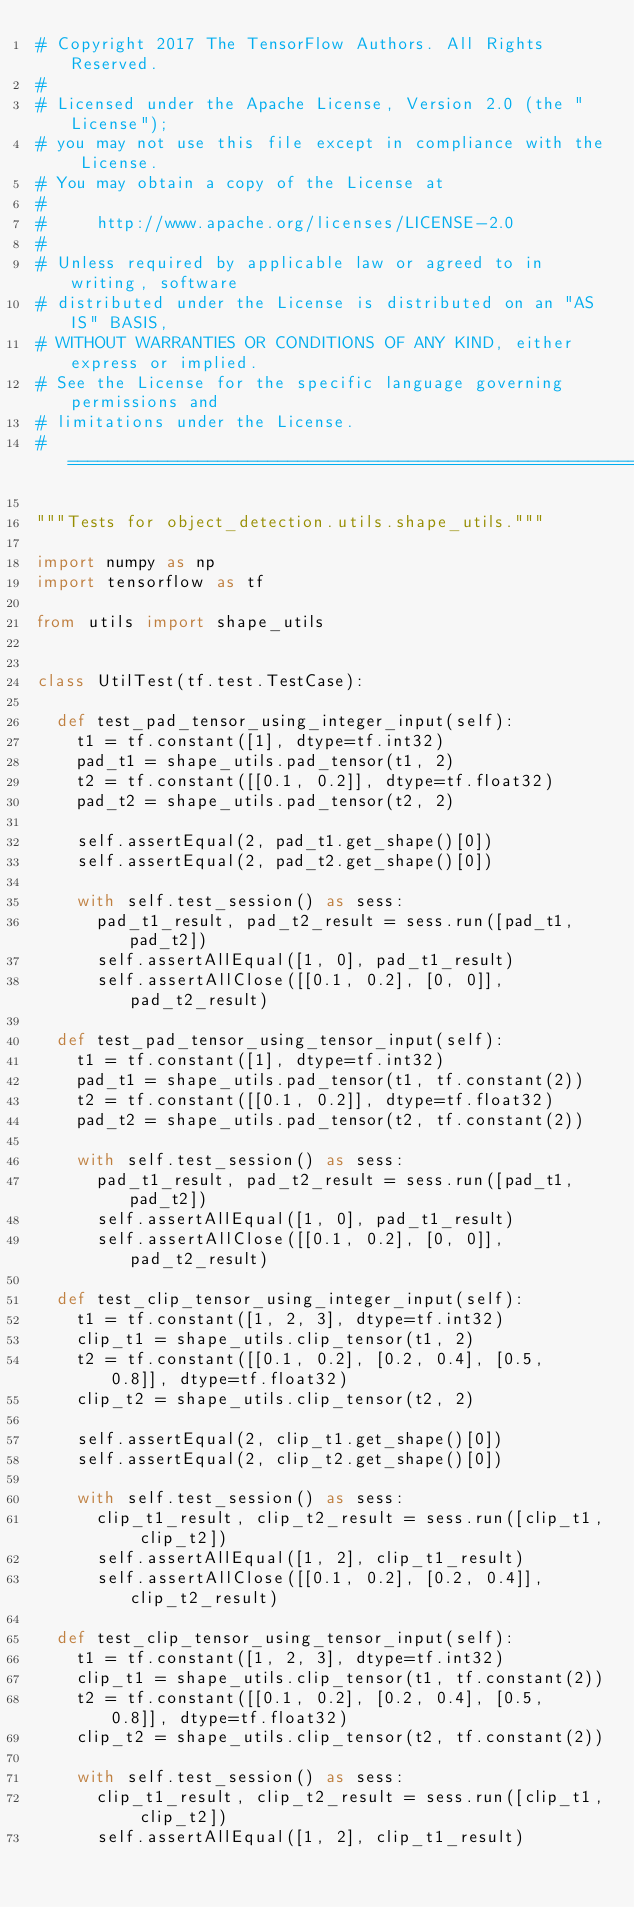<code> <loc_0><loc_0><loc_500><loc_500><_Python_># Copyright 2017 The TensorFlow Authors. All Rights Reserved.
#
# Licensed under the Apache License, Version 2.0 (the "License");
# you may not use this file except in compliance with the License.
# You may obtain a copy of the License at
#
#     http://www.apache.org/licenses/LICENSE-2.0
#
# Unless required by applicable law or agreed to in writing, software
# distributed under the License is distributed on an "AS IS" BASIS,
# WITHOUT WARRANTIES OR CONDITIONS OF ANY KIND, either express or implied.
# See the License for the specific language governing permissions and
# limitations under the License.
# ==============================================================================

"""Tests for object_detection.utils.shape_utils."""

import numpy as np
import tensorflow as tf

from utils import shape_utils


class UtilTest(tf.test.TestCase):

  def test_pad_tensor_using_integer_input(self):
    t1 = tf.constant([1], dtype=tf.int32)
    pad_t1 = shape_utils.pad_tensor(t1, 2)
    t2 = tf.constant([[0.1, 0.2]], dtype=tf.float32)
    pad_t2 = shape_utils.pad_tensor(t2, 2)

    self.assertEqual(2, pad_t1.get_shape()[0])
    self.assertEqual(2, pad_t2.get_shape()[0])

    with self.test_session() as sess:
      pad_t1_result, pad_t2_result = sess.run([pad_t1, pad_t2])
      self.assertAllEqual([1, 0], pad_t1_result)
      self.assertAllClose([[0.1, 0.2], [0, 0]], pad_t2_result)

  def test_pad_tensor_using_tensor_input(self):
    t1 = tf.constant([1], dtype=tf.int32)
    pad_t1 = shape_utils.pad_tensor(t1, tf.constant(2))
    t2 = tf.constant([[0.1, 0.2]], dtype=tf.float32)
    pad_t2 = shape_utils.pad_tensor(t2, tf.constant(2))

    with self.test_session() as sess:
      pad_t1_result, pad_t2_result = sess.run([pad_t1, pad_t2])
      self.assertAllEqual([1, 0], pad_t1_result)
      self.assertAllClose([[0.1, 0.2], [0, 0]], pad_t2_result)

  def test_clip_tensor_using_integer_input(self):
    t1 = tf.constant([1, 2, 3], dtype=tf.int32)
    clip_t1 = shape_utils.clip_tensor(t1, 2)
    t2 = tf.constant([[0.1, 0.2], [0.2, 0.4], [0.5, 0.8]], dtype=tf.float32)
    clip_t2 = shape_utils.clip_tensor(t2, 2)

    self.assertEqual(2, clip_t1.get_shape()[0])
    self.assertEqual(2, clip_t2.get_shape()[0])

    with self.test_session() as sess:
      clip_t1_result, clip_t2_result = sess.run([clip_t1, clip_t2])
      self.assertAllEqual([1, 2], clip_t1_result)
      self.assertAllClose([[0.1, 0.2], [0.2, 0.4]], clip_t2_result)

  def test_clip_tensor_using_tensor_input(self):
    t1 = tf.constant([1, 2, 3], dtype=tf.int32)
    clip_t1 = shape_utils.clip_tensor(t1, tf.constant(2))
    t2 = tf.constant([[0.1, 0.2], [0.2, 0.4], [0.5, 0.8]], dtype=tf.float32)
    clip_t2 = shape_utils.clip_tensor(t2, tf.constant(2))

    with self.test_session() as sess:
      clip_t1_result, clip_t2_result = sess.run([clip_t1, clip_t2])
      self.assertAllEqual([1, 2], clip_t1_result)</code> 